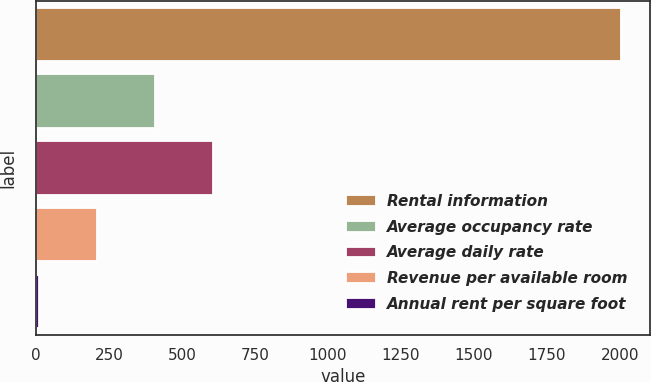Convert chart. <chart><loc_0><loc_0><loc_500><loc_500><bar_chart><fcel>Rental information<fcel>Average occupancy rate<fcel>Average daily rate<fcel>Revenue per available room<fcel>Annual rent per square foot<nl><fcel>2003<fcel>408.54<fcel>607.85<fcel>209.23<fcel>9.92<nl></chart> 